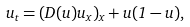<formula> <loc_0><loc_0><loc_500><loc_500>u _ { t } = ( D ( u ) u _ { x } ) _ { x } + u ( 1 - u ) ,</formula> 